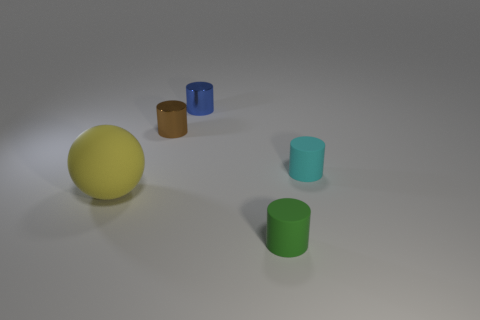Add 1 cyan metal balls. How many objects exist? 6 Subtract all tiny blue cylinders. How many cylinders are left? 3 Subtract all blue cylinders. How many cylinders are left? 3 Subtract all cylinders. How many objects are left? 1 Subtract all red cylinders. How many blue spheres are left? 0 Add 4 small blue shiny things. How many small blue shiny things are left? 5 Add 3 green metallic cubes. How many green metallic cubes exist? 3 Subtract 1 cyan cylinders. How many objects are left? 4 Subtract all red cylinders. Subtract all yellow blocks. How many cylinders are left? 4 Subtract all big blue spheres. Subtract all blue cylinders. How many objects are left? 4 